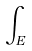<formula> <loc_0><loc_0><loc_500><loc_500>\int _ { E }</formula> 